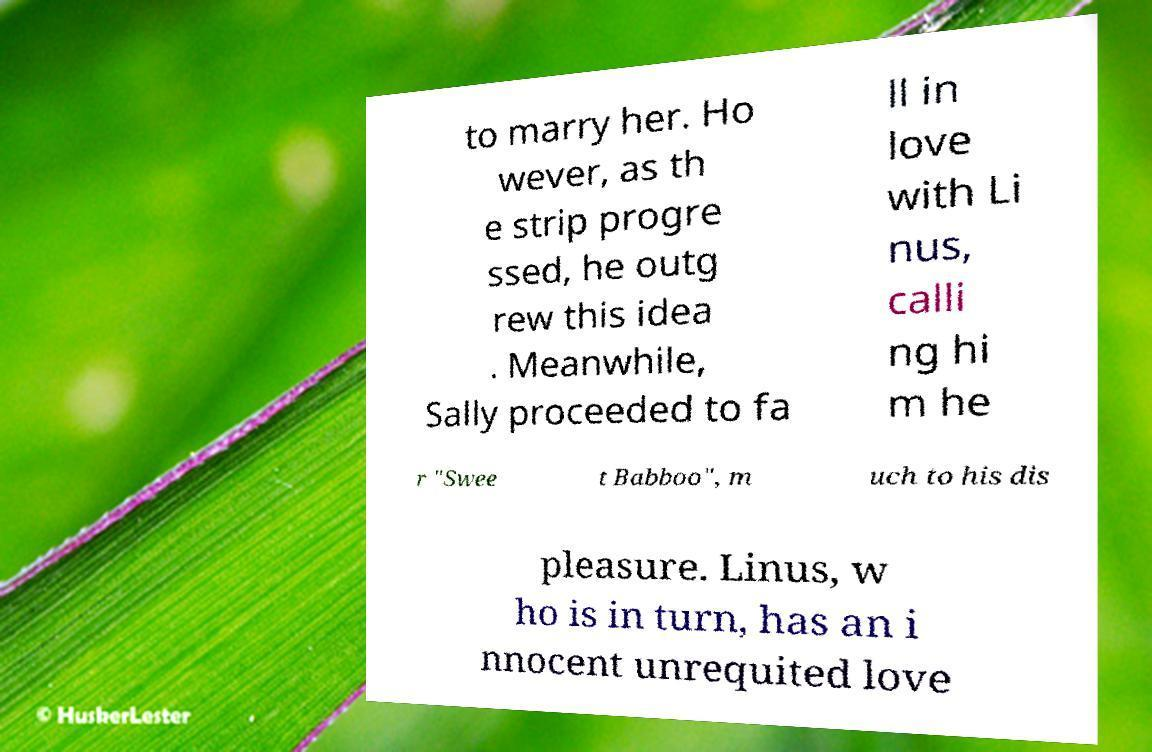Please identify and transcribe the text found in this image. to marry her. Ho wever, as th e strip progre ssed, he outg rew this idea . Meanwhile, Sally proceeded to fa ll in love with Li nus, calli ng hi m he r "Swee t Babboo", m uch to his dis pleasure. Linus, w ho is in turn, has an i nnocent unrequited love 